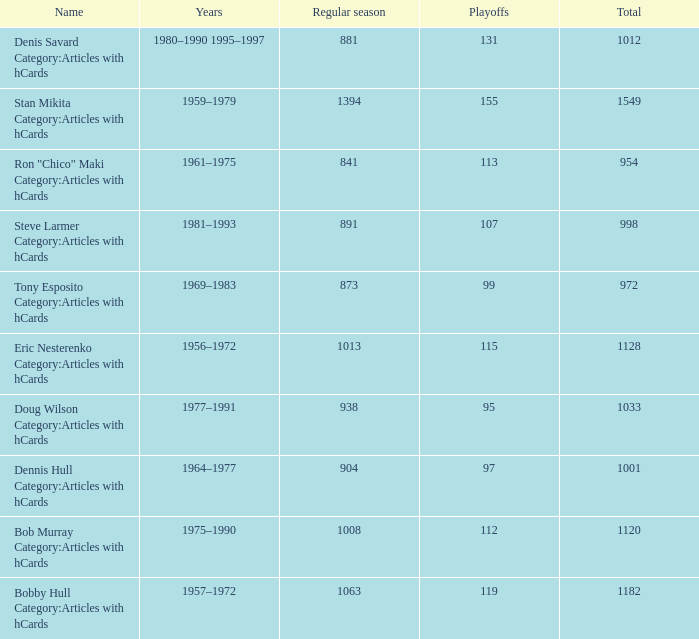How may times is regular season 1063 and playoffs more than 119? 0.0. 